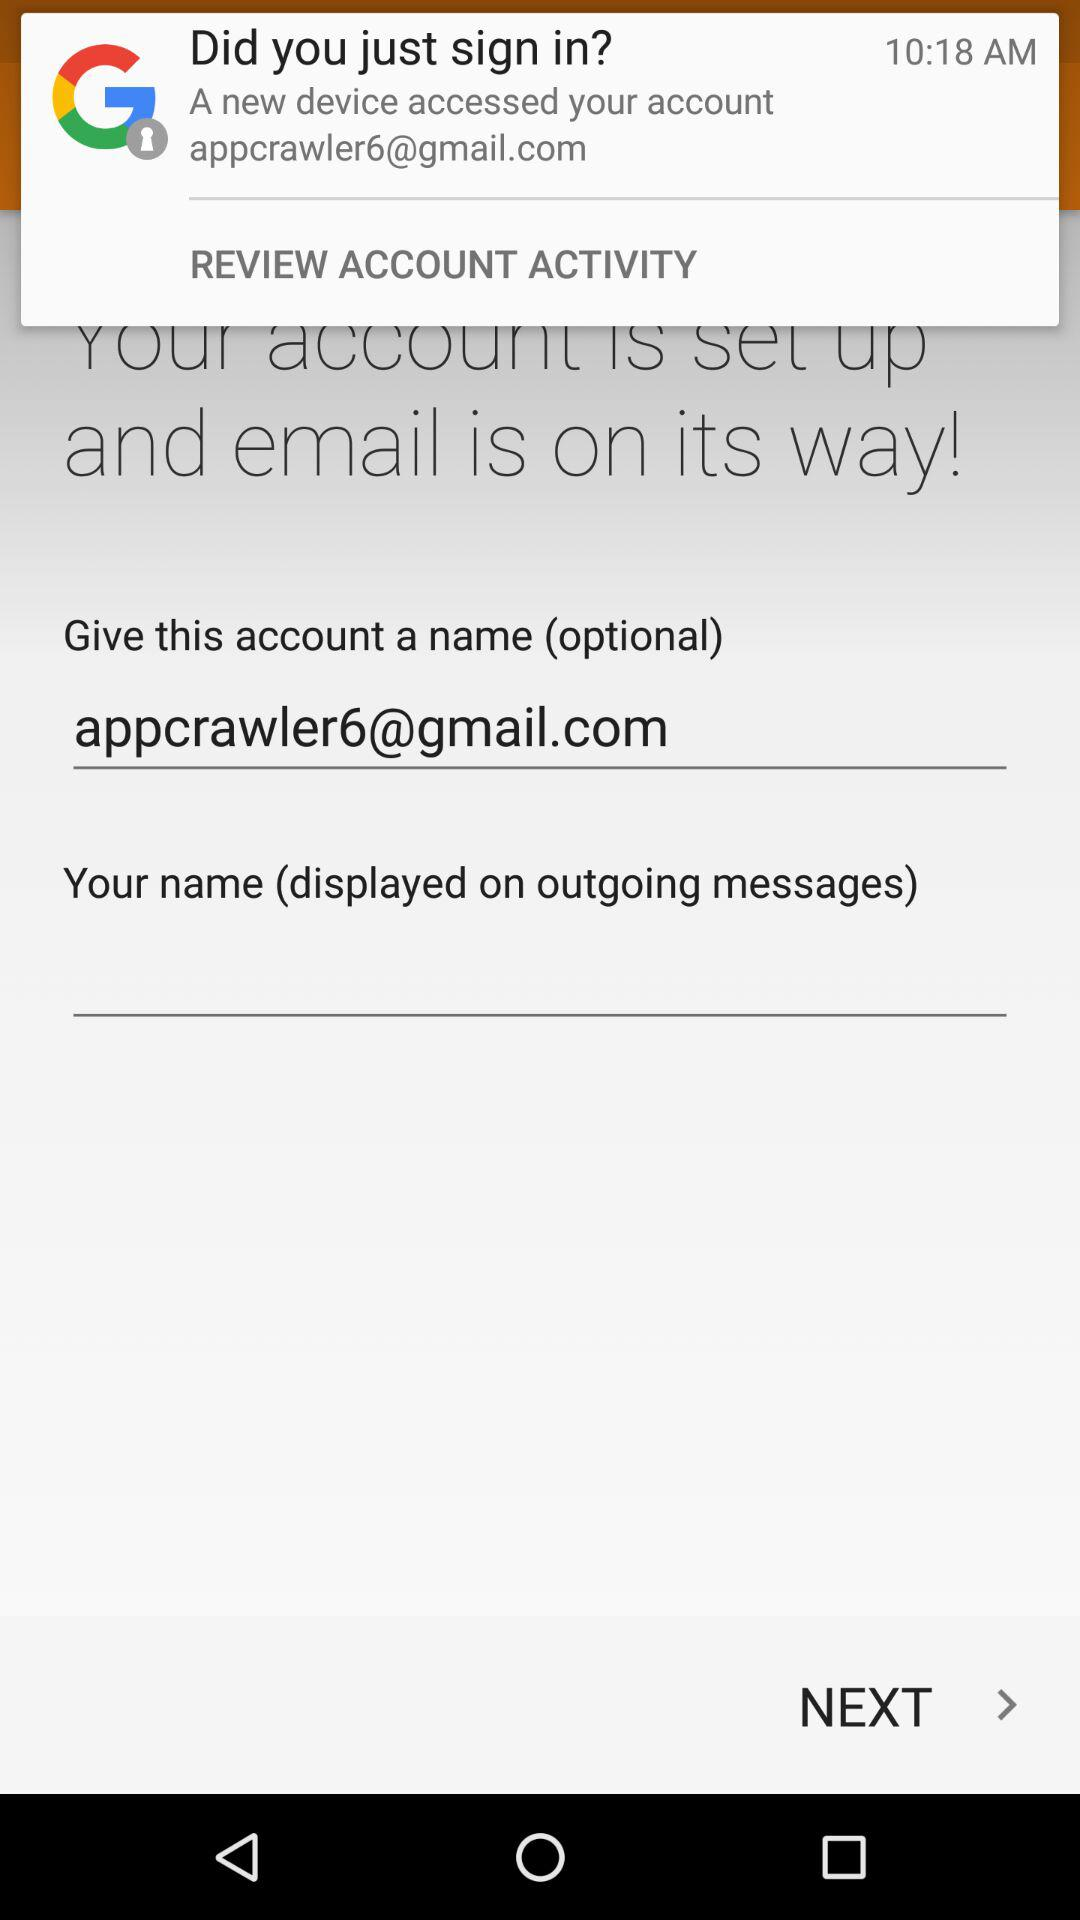What is the e-mail address? The e-mail address is appcrawler6@gmail.com. 